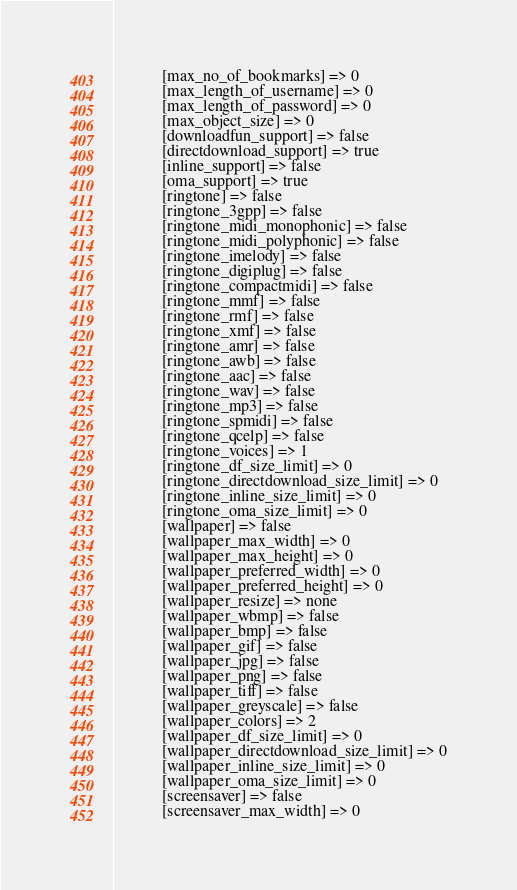Convert code to text. <code><loc_0><loc_0><loc_500><loc_500><_HTML_>            [max_no_of_bookmarks] => 0
            [max_length_of_username] => 0
            [max_length_of_password] => 0
            [max_object_size] => 0
            [downloadfun_support] => false
            [directdownload_support] => true
            [inline_support] => false
            [oma_support] => true
            [ringtone] => false
            [ringtone_3gpp] => false
            [ringtone_midi_monophonic] => false
            [ringtone_midi_polyphonic] => false
            [ringtone_imelody] => false
            [ringtone_digiplug] => false
            [ringtone_compactmidi] => false
            [ringtone_mmf] => false
            [ringtone_rmf] => false
            [ringtone_xmf] => false
            [ringtone_amr] => false
            [ringtone_awb] => false
            [ringtone_aac] => false
            [ringtone_wav] => false
            [ringtone_mp3] => false
            [ringtone_spmidi] => false
            [ringtone_qcelp] => false
            [ringtone_voices] => 1
            [ringtone_df_size_limit] => 0
            [ringtone_directdownload_size_limit] => 0
            [ringtone_inline_size_limit] => 0
            [ringtone_oma_size_limit] => 0
            [wallpaper] => false
            [wallpaper_max_width] => 0
            [wallpaper_max_height] => 0
            [wallpaper_preferred_width] => 0
            [wallpaper_preferred_height] => 0
            [wallpaper_resize] => none
            [wallpaper_wbmp] => false
            [wallpaper_bmp] => false
            [wallpaper_gif] => false
            [wallpaper_jpg] => false
            [wallpaper_png] => false
            [wallpaper_tiff] => false
            [wallpaper_greyscale] => false
            [wallpaper_colors] => 2
            [wallpaper_df_size_limit] => 0
            [wallpaper_directdownload_size_limit] => 0
            [wallpaper_inline_size_limit] => 0
            [wallpaper_oma_size_limit] => 0
            [screensaver] => false
            [screensaver_max_width] => 0</code> 